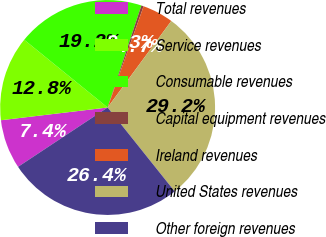<chart> <loc_0><loc_0><loc_500><loc_500><pie_chart><fcel>Total revenues<fcel>Service revenues<fcel>Consumable revenues<fcel>Capital equipment revenues<fcel>Ireland revenues<fcel>United States revenues<fcel>Other foreign revenues<nl><fcel>7.42%<fcel>12.75%<fcel>19.23%<fcel>0.35%<fcel>4.66%<fcel>29.17%<fcel>26.42%<nl></chart> 